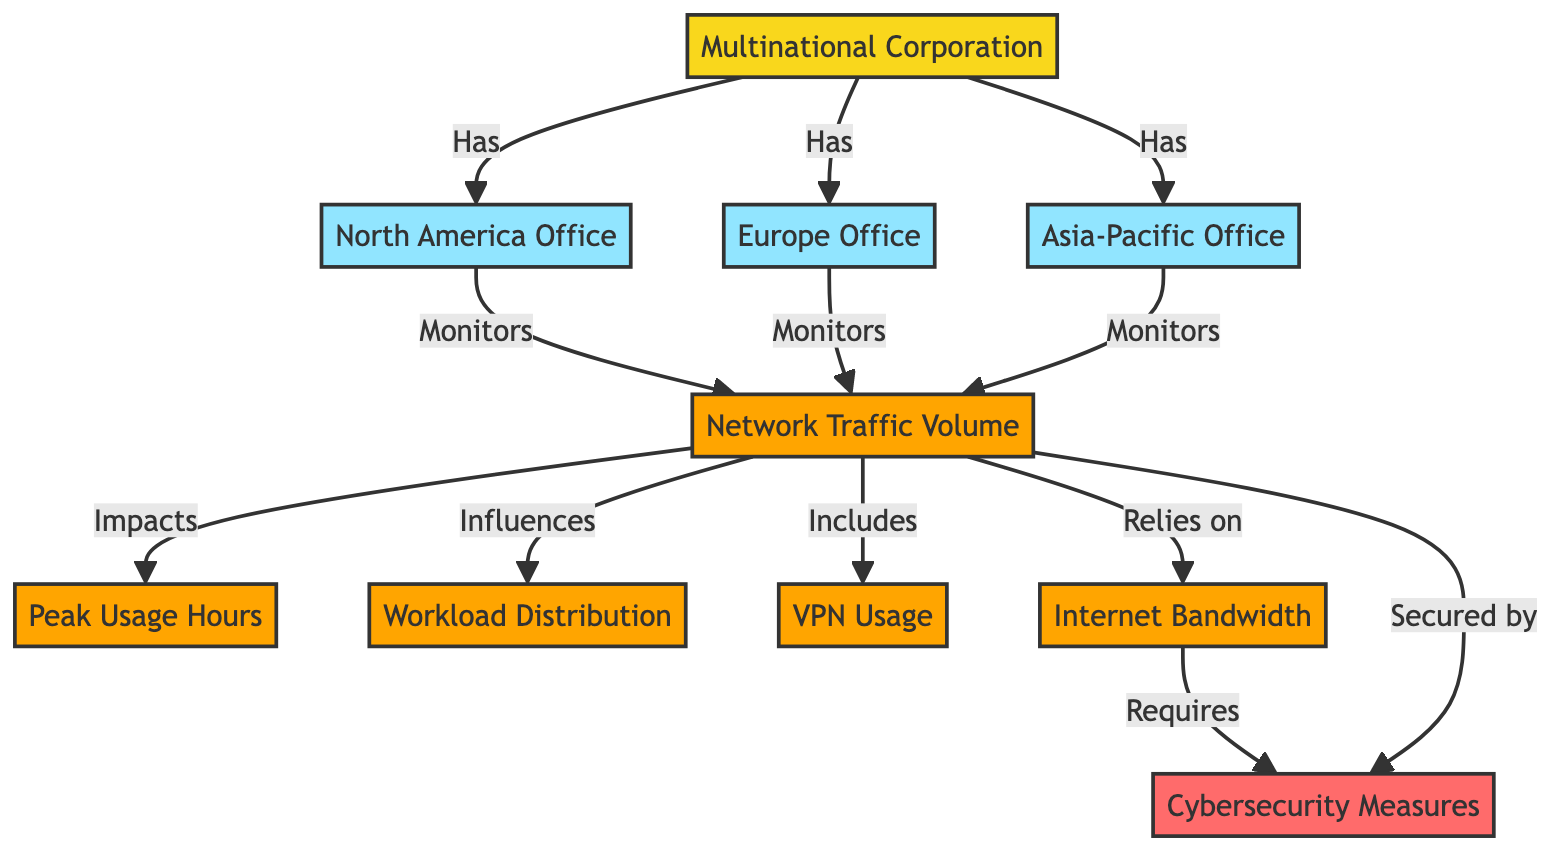What are the three offices belonging to the multinational corporation? The diagram clearly lists three offices: North America Office, Europe Office, and Asia-Pacific Office, all of which are directly connected to the multinational corporation node.
Answer: North America Office, Europe Office, Asia-Pacific Office Which metric does the network traffic volume impact directly? The diagram shows a directional relationship where "Network Traffic Volume" points to "Peak Usage Hours," indicating that network traffic volume has a direct impact on peak usage hours.
Answer: Peak Usage Hours How many metrics are monitored by the corporation's offices? Each of the three offices (North America, Europe, Asia-Pacific) monitors one metric in the diagram, namely the "Network Traffic Volume," resulting in a total of three monitoring relationships.
Answer: 1 What does network traffic volume influence according to the diagram? The diagram indicates that "Network Traffic Volume" influences "Workload Distribution," providing a direct linkage between these two metrics.
Answer: Workload Distribution Which metric requires cybersecurity measures? The diagram illustrates that "Internet Bandwidth" is linked to "Cybersecurity Measures" with a "Requires" relationship, indicating that cybersecurity measures are necessary for internet bandwidth management.
Answer: Cybersecurity Measures What is the class color of the multinational corporation node? In the diagram, the multinational corporation node is defined with the class color 'fill:#f9d71c,' which corresponds to the shade representing the corporation category in the diagram.
Answer: Yellow How many directed relationships does the "Network Traffic Volume" have in the diagram? The "Network Traffic Volume" establishes five directed relationships, as indicated by the arrows pointing from it to "Peak Usage Hours," "Workload Distribution," "VPN Usage," "Internet Bandwidth," and "Cybersecurity Measures."
Answer: 5 What is the relationship between Internet Bandwidth and Cybersecurity Measures? The diagram shows that "Internet Bandwidth" requires "Cybersecurity Measures," indicating that cybersecurity protocols are necessary for protecting the bandwidth used by the corporation.
Answer: Requires Which office monitors the network traffic volume? All three offices (North America Office, Europe Office, and Asia-Pacific Office) are linked to monitor the "Network Traffic Volume," confirming that each office is responsible for its observation.
Answer: All Offices 